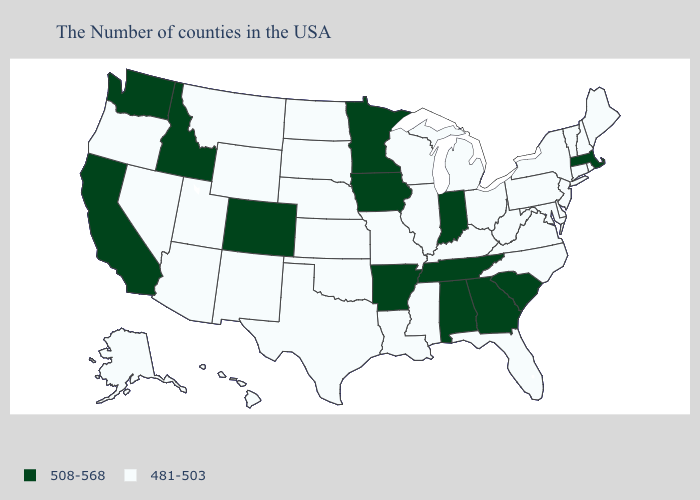What is the value of West Virginia?
Concise answer only. 481-503. What is the highest value in states that border South Carolina?
Be succinct. 508-568. Does Wyoming have the same value as Alabama?
Give a very brief answer. No. How many symbols are there in the legend?
Keep it brief. 2. What is the value of California?
Short answer required. 508-568. What is the value of Tennessee?
Short answer required. 508-568. What is the highest value in states that border New Jersey?
Write a very short answer. 481-503. What is the lowest value in the USA?
Keep it brief. 481-503. Which states have the highest value in the USA?
Keep it brief. Massachusetts, South Carolina, Georgia, Indiana, Alabama, Tennessee, Arkansas, Minnesota, Iowa, Colorado, Idaho, California, Washington. What is the lowest value in the USA?
Quick response, please. 481-503. How many symbols are there in the legend?
Short answer required. 2. Name the states that have a value in the range 508-568?
Short answer required. Massachusetts, South Carolina, Georgia, Indiana, Alabama, Tennessee, Arkansas, Minnesota, Iowa, Colorado, Idaho, California, Washington. What is the lowest value in the USA?
Write a very short answer. 481-503. What is the value of Alaska?
Concise answer only. 481-503. Which states have the lowest value in the USA?
Quick response, please. Maine, Rhode Island, New Hampshire, Vermont, Connecticut, New York, New Jersey, Delaware, Maryland, Pennsylvania, Virginia, North Carolina, West Virginia, Ohio, Florida, Michigan, Kentucky, Wisconsin, Illinois, Mississippi, Louisiana, Missouri, Kansas, Nebraska, Oklahoma, Texas, South Dakota, North Dakota, Wyoming, New Mexico, Utah, Montana, Arizona, Nevada, Oregon, Alaska, Hawaii. 